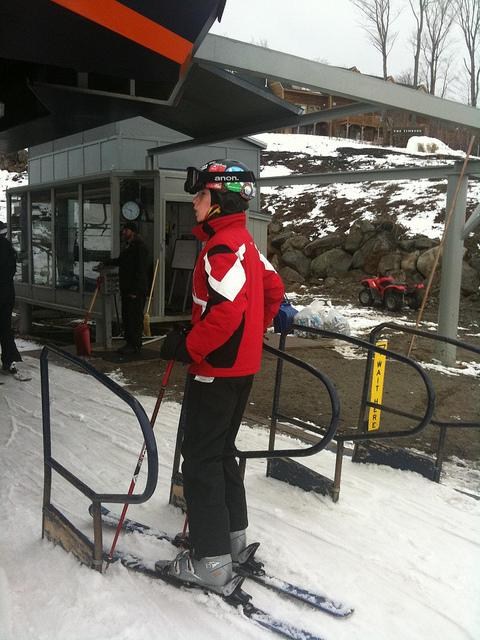What are the bars for? Please explain your reasoning. stand waiting. Aside from the person, the bars do not hold anything. the person will take the lift, but it is not there yet. 